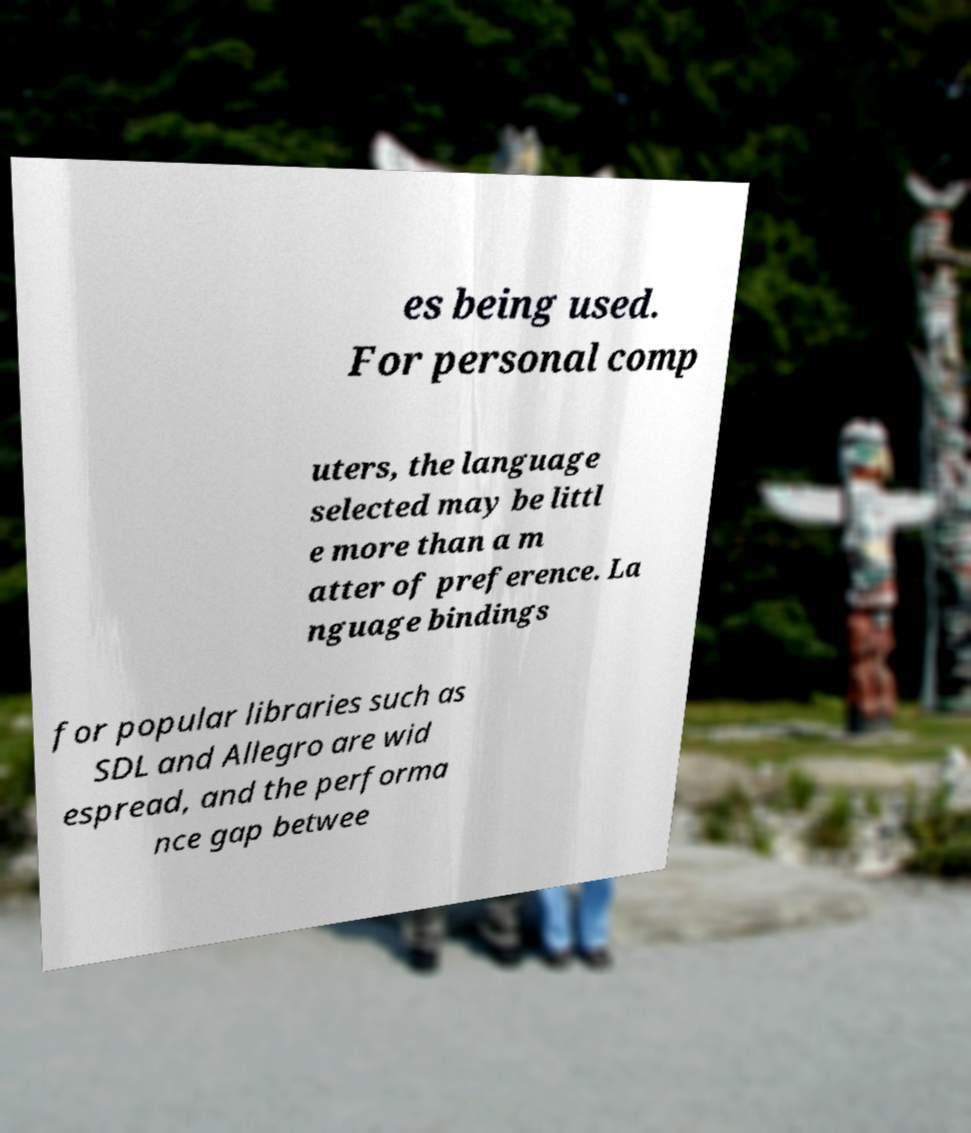Please identify and transcribe the text found in this image. es being used. For personal comp uters, the language selected may be littl e more than a m atter of preference. La nguage bindings for popular libraries such as SDL and Allegro are wid espread, and the performa nce gap betwee 